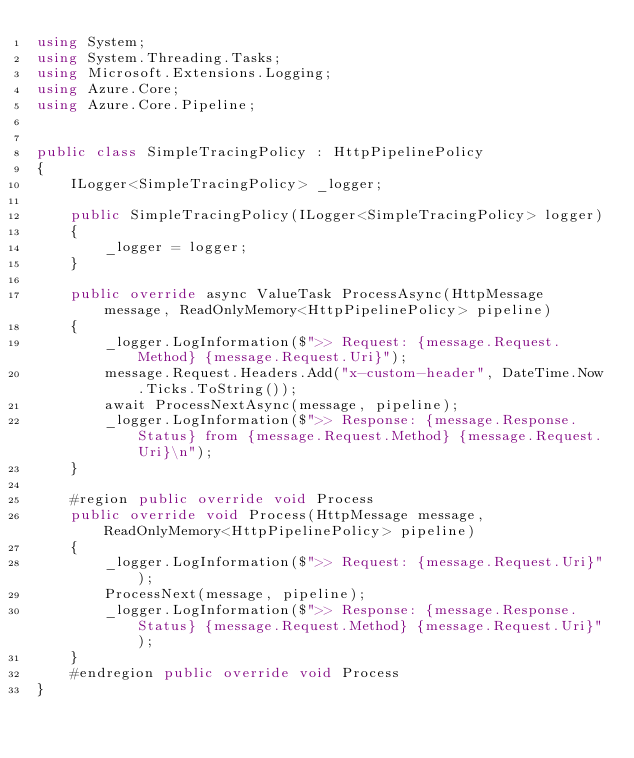Convert code to text. <code><loc_0><loc_0><loc_500><loc_500><_C#_>using System;
using System.Threading.Tasks;
using Microsoft.Extensions.Logging;
using Azure.Core;
using Azure.Core.Pipeline;


public class SimpleTracingPolicy : HttpPipelinePolicy
{
    ILogger<SimpleTracingPolicy> _logger;

    public SimpleTracingPolicy(ILogger<SimpleTracingPolicy> logger)
    {
        _logger = logger;
    }

    public override async ValueTask ProcessAsync(HttpMessage message, ReadOnlyMemory<HttpPipelinePolicy> pipeline)
    {
        _logger.LogInformation($">> Request: {message.Request.Method} {message.Request.Uri}");
        message.Request.Headers.Add("x-custom-header", DateTime.Now.Ticks.ToString());
        await ProcessNextAsync(message, pipeline);
        _logger.LogInformation($">> Response: {message.Response.Status} from {message.Request.Method} {message.Request.Uri}\n");
    }

    #region public override void Process
    public override void Process(HttpMessage message, ReadOnlyMemory<HttpPipelinePolicy> pipeline)
    {
        _logger.LogInformation($">> Request: {message.Request.Uri}");
        ProcessNext(message, pipeline);
        _logger.LogInformation($">> Response: {message.Response.Status} {message.Request.Method} {message.Request.Uri}");
    }
    #endregion public override void Process
}</code> 